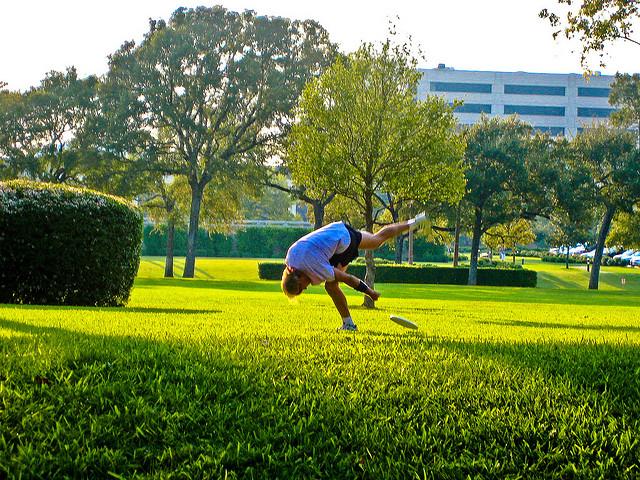Where is the frisbee?
Write a very short answer. On ground. What is the person doing?
Give a very brief answer. Frisbee. Is this a rural area?
Give a very brief answer. No. 